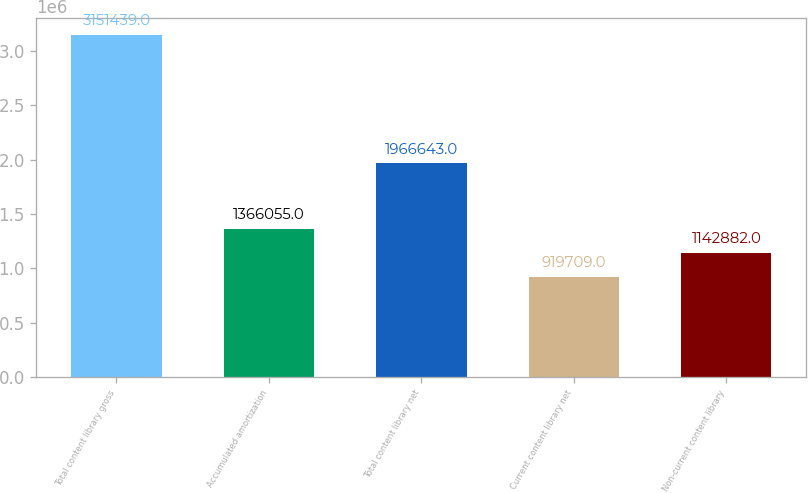<chart> <loc_0><loc_0><loc_500><loc_500><bar_chart><fcel>Total content library gross<fcel>Accumulated amortization<fcel>Total content library net<fcel>Current content library net<fcel>Non-current content library<nl><fcel>3.15144e+06<fcel>1.36606e+06<fcel>1.96664e+06<fcel>919709<fcel>1.14288e+06<nl></chart> 